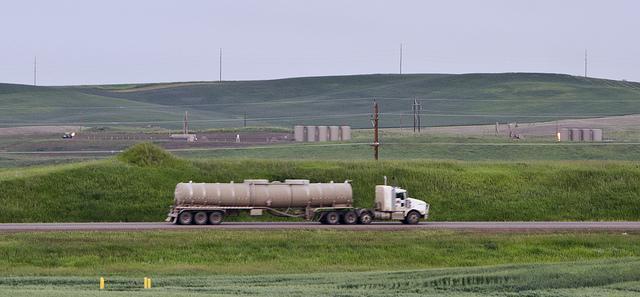How many poles are on the crest of the hill in the background?
Give a very brief answer. 4. How many tires are on the truck?
Give a very brief answer. 14. How many people are wearing white pants?
Give a very brief answer. 0. 